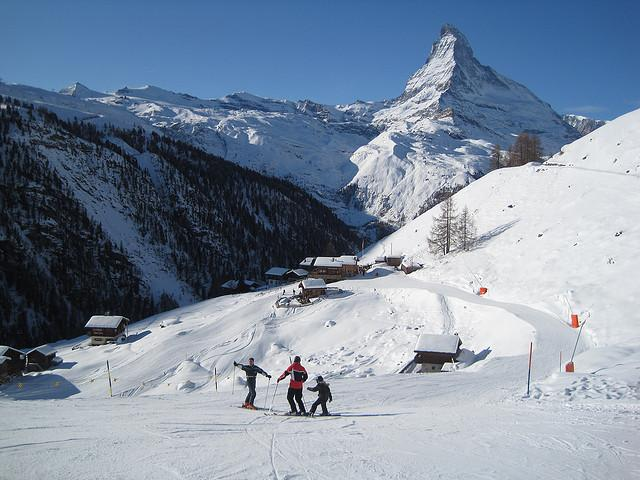What types of trees are these? pine trees 